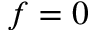Convert formula to latex. <formula><loc_0><loc_0><loc_500><loc_500>f = 0</formula> 